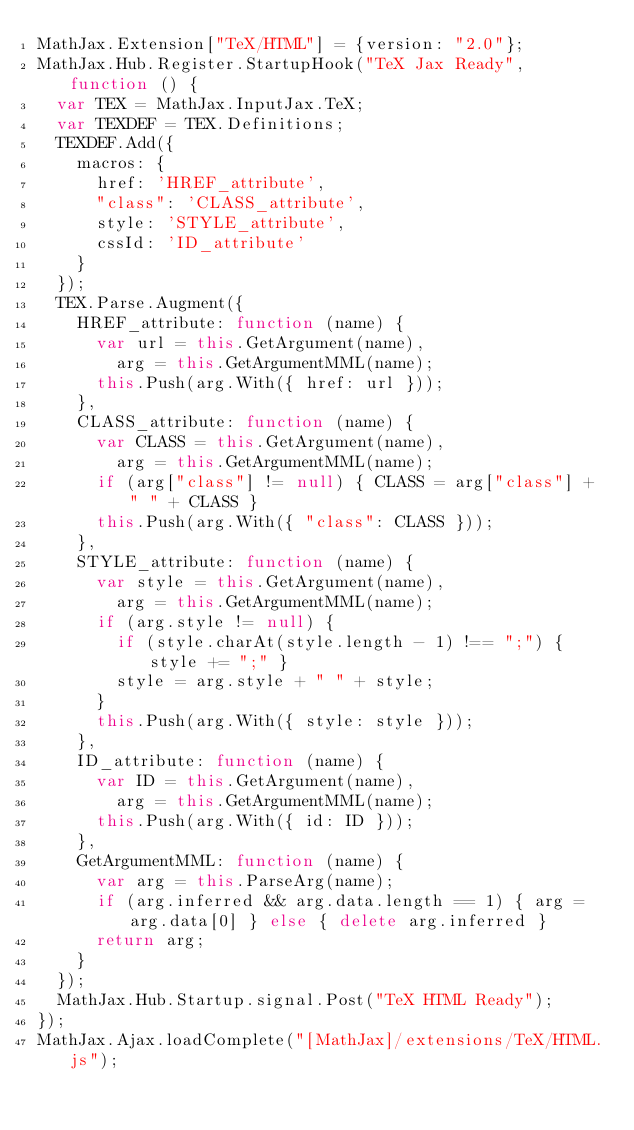Convert code to text. <code><loc_0><loc_0><loc_500><loc_500><_JavaScript_>MathJax.Extension["TeX/HTML"] = {version: "2.0"};
MathJax.Hub.Register.StartupHook("TeX Jax Ready", function () {
  var TEX = MathJax.InputJax.TeX;
  var TEXDEF = TEX.Definitions;
  TEXDEF.Add({
    macros: {
      href: 'HREF_attribute',
      "class": 'CLASS_attribute',
      style: 'STYLE_attribute',
      cssId: 'ID_attribute'
    }
  });
  TEX.Parse.Augment({
    HREF_attribute: function (name) {
      var url = this.GetArgument(name),
        arg = this.GetArgumentMML(name);
      this.Push(arg.With({ href: url }));
    },
    CLASS_attribute: function (name) {
      var CLASS = this.GetArgument(name),
        arg = this.GetArgumentMML(name);
      if (arg["class"] != null) { CLASS = arg["class"] + " " + CLASS }
      this.Push(arg.With({ "class": CLASS }));
    },
    STYLE_attribute: function (name) {
      var style = this.GetArgument(name),
        arg = this.GetArgumentMML(name);
      if (arg.style != null) {
        if (style.charAt(style.length - 1) !== ";") { style += ";" }
        style = arg.style + " " + style;
      }
      this.Push(arg.With({ style: style }));
    },
    ID_attribute: function (name) {
      var ID = this.GetArgument(name),
        arg = this.GetArgumentMML(name);
      this.Push(arg.With({ id: ID }));
    },
    GetArgumentMML: function (name) {
      var arg = this.ParseArg(name);
      if (arg.inferred && arg.data.length == 1) { arg = arg.data[0] } else { delete arg.inferred }
      return arg;
    }
  });
  MathJax.Hub.Startup.signal.Post("TeX HTML Ready");
});
MathJax.Ajax.loadComplete("[MathJax]/extensions/TeX/HTML.js");
</code> 